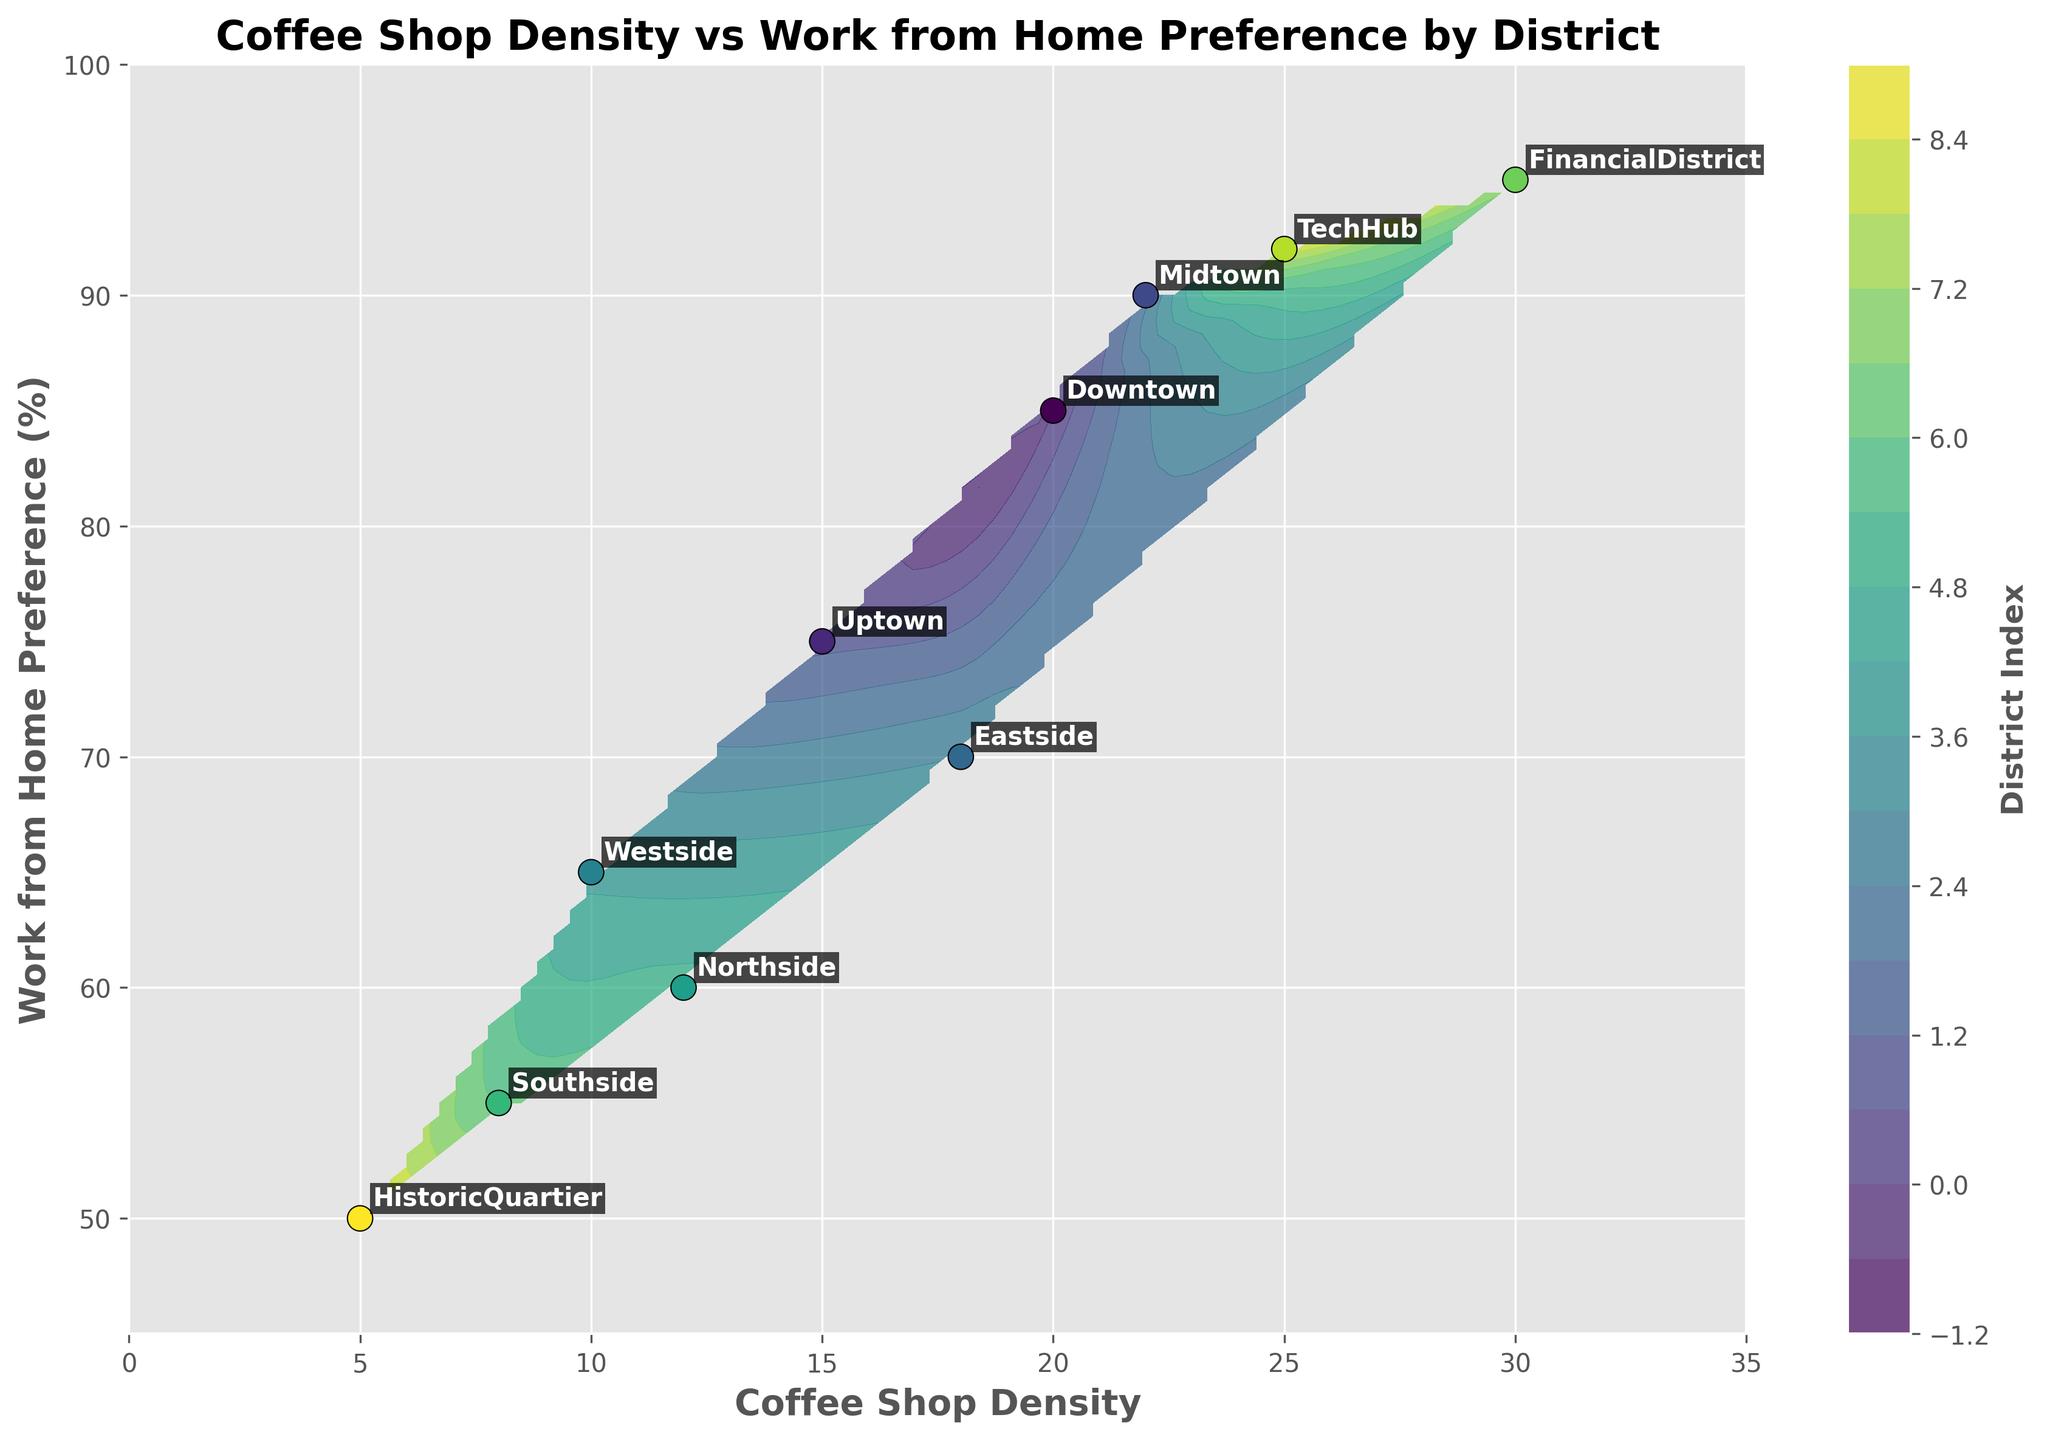1. What is the title of the contour plot? The title of the graph is displayed at the top center of the plot.
Answer: Coffee Shop Density vs Work from Home Preference by District 2. What are the x and y-axes labeled as? The plot includes labeled axes; the x-axis represents 'Coffee Shop Density,' and the y-axis represents 'Work from Home Preference (%)'.
Answer: Coffee Shop Density and Work from Home Preference (%) 3. Which district has the highest coffee shop density, and how does it compare to its work-from-home preference? The district with the highest coffee shop density can be identified by looking at the x-axis value, which is the Financial District. Financial District's position on the y-axis indicates a very high work-from-home preference.
Answer: Financial District, very high Work from Home Preference 4. Compare the Work from Home Preference between Northside and Southside. Locate Northside and Southside on the plot by their y-axis values. Northside has a higher work-from-home preference at 60%, compared to Southside's 55%.
Answer: Northside > Southside 5. What district has the lowest coffee shop density, and what is its work-from-home preference? By looking at the x-axis for the lowest density, the Historic Quartier has the lowest value, and its y-axis shows a work-from-home preference of 50%.
Answer: Historic Quartier, 50% 6. Which district shows the most balanced coffee shop density and a strong preference for working from home? Look for districts that are well balanced on both axes, TechHub stands out with a coffee shop density of 25 and a work-from-home preference of 92%.
Answer: TechHub 7. Which districts have a work-from-home preference greater than 85%? To find these districts, locate points on the y-axis above the 85% mark; the relevant districts are Downtown, Midtown, Financial District, and TechHub.
Answer: Downtown, Midtown, Financial District, TechHub 8. Is there any district with both low coffee shop density and low work-from-home preference? Search for points on the lower left part of the plot; Historic Quartier fits this with a coffee shop density of 5 and a work-from-home preference of 50%.
Answer: Historic Quartier 9. What is the difference in coffee shop density between Downtown and Westside? Determine the x-axis values of Downtown and Westside; Downtown is at 20, and Westside at 10, so the difference is 10.
Answer: 10 10. Which district's label appears closest to the contour center? The scatter plot's annotated district labels show that the midpoint of the contours seems closest to the Northside district label.
Answer: Northside 